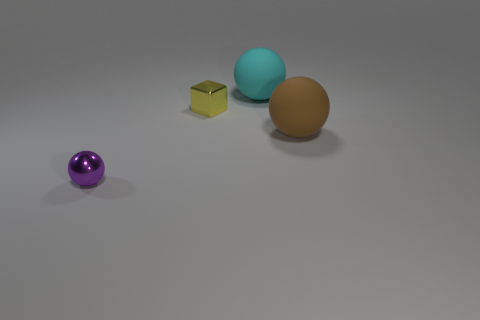What size is the purple metal thing that is the same shape as the cyan object?
Your response must be concise. Small. What color is the other large thing that is the same shape as the big brown thing?
Your answer should be compact. Cyan. Is the color of the tiny cube the same as the tiny shiny ball?
Offer a terse response. No. What number of objects are either small things right of the tiny shiny sphere or tiny purple spheres?
Provide a short and direct response. 2. There is a large thing in front of the metallic thing that is behind the tiny shiny object that is in front of the big brown ball; what is its color?
Your response must be concise. Brown. What color is the thing that is the same material as the big cyan ball?
Offer a very short reply. Brown. How many big cyan spheres have the same material as the tiny yellow cube?
Your answer should be compact. 0. Do the metallic thing that is behind the brown ball and the small metal sphere have the same size?
Provide a succinct answer. Yes. What is the color of the shiny thing that is the same size as the yellow metallic block?
Offer a terse response. Purple. There is a brown object; how many yellow shiny cubes are behind it?
Your answer should be very brief. 1. 